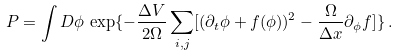Convert formula to latex. <formula><loc_0><loc_0><loc_500><loc_500>P = \int D \phi \, \exp \{ - \frac { \Delta V } { 2 \Omega } \sum _ { i , j } [ ( \partial _ { t } { \phi } + f ( \phi ) ) ^ { 2 } - \frac { \Omega } { \Delta x } \partial _ { \phi } f ] \} \, .</formula> 